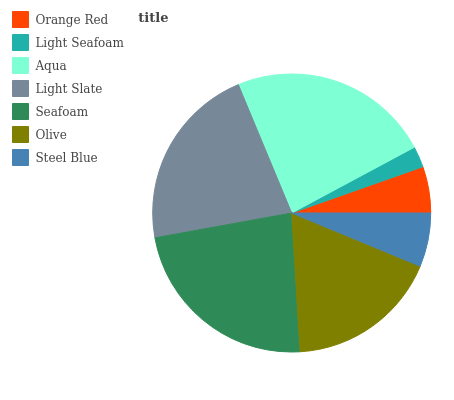Is Light Seafoam the minimum?
Answer yes or no. Yes. Is Aqua the maximum?
Answer yes or no. Yes. Is Aqua the minimum?
Answer yes or no. No. Is Light Seafoam the maximum?
Answer yes or no. No. Is Aqua greater than Light Seafoam?
Answer yes or no. Yes. Is Light Seafoam less than Aqua?
Answer yes or no. Yes. Is Light Seafoam greater than Aqua?
Answer yes or no. No. Is Aqua less than Light Seafoam?
Answer yes or no. No. Is Olive the high median?
Answer yes or no. Yes. Is Olive the low median?
Answer yes or no. Yes. Is Seafoam the high median?
Answer yes or no. No. Is Seafoam the low median?
Answer yes or no. No. 